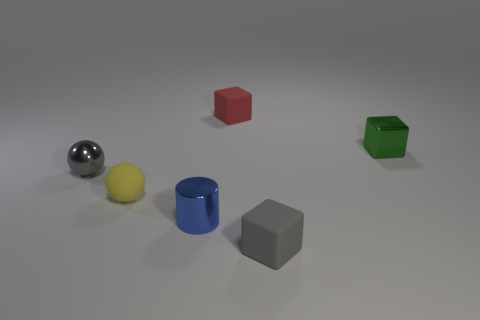Is the size of the gray thing to the right of the red rubber cube the same as the green metallic block?
Provide a short and direct response. Yes. What number of gray objects are in front of the small shiny sphere?
Offer a very short reply. 1. The small object that is right of the red cube and behind the blue metallic cylinder is made of what material?
Keep it short and to the point. Metal. How many tiny things are either blocks or yellow matte spheres?
Offer a terse response. 4. The gray rubber object has what size?
Your answer should be very brief. Small. What is the shape of the blue metallic object?
Ensure brevity in your answer.  Cylinder. Is there anything else that is the same shape as the small red matte object?
Your answer should be compact. Yes. Are there fewer metal spheres to the left of the small metallic ball than tiny rubber blocks?
Ensure brevity in your answer.  Yes. Does the sphere in front of the gray metallic sphere have the same color as the small cylinder?
Provide a succinct answer. No. How many shiny things are large green balls or gray things?
Your response must be concise. 1. 